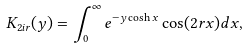Convert formula to latex. <formula><loc_0><loc_0><loc_500><loc_500>K _ { 2 i r } ( y ) = \int _ { 0 } ^ { \infty } e ^ { - y \cosh x } \cos ( 2 r x ) d x ,</formula> 